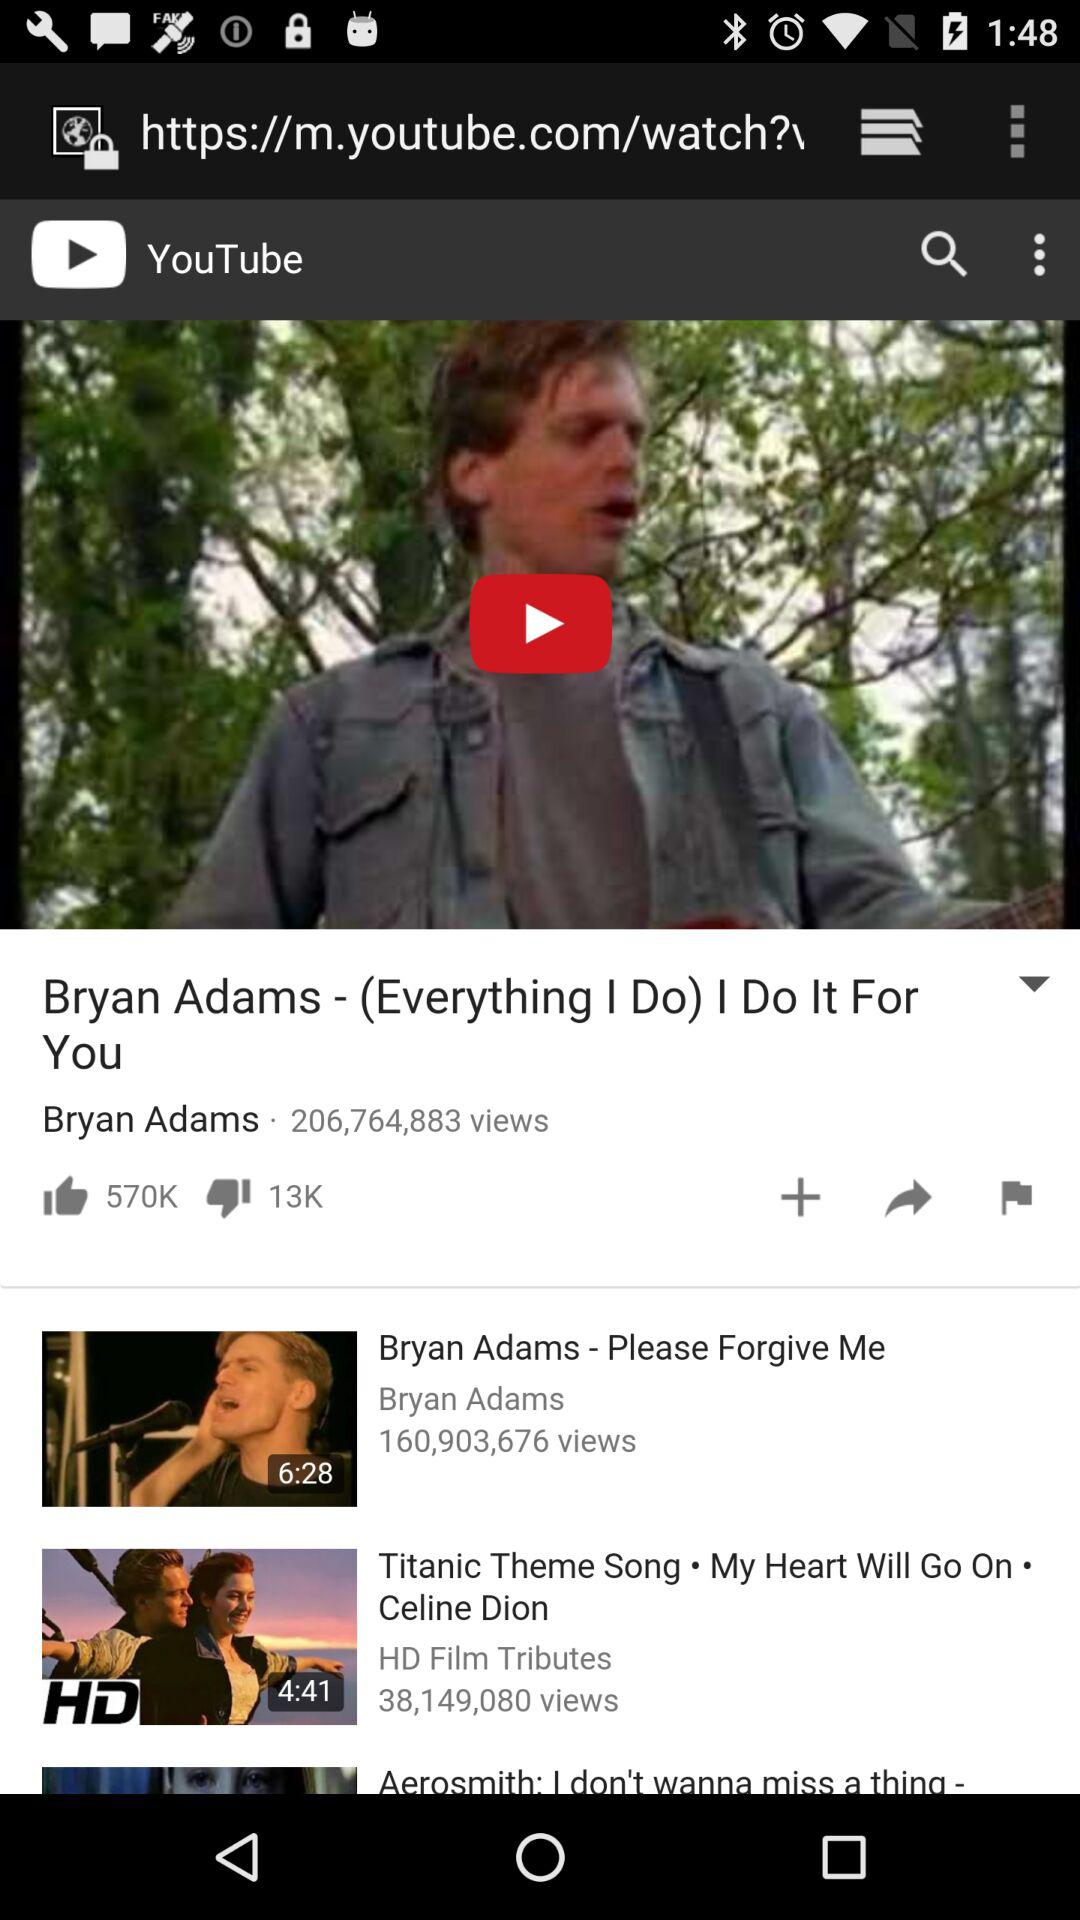How many people have seen the "Bryan Adams - Please Forgive Me"? The number of people who have seen the "Bryan Adams - Please Forgive Me" is 160,903,676. 